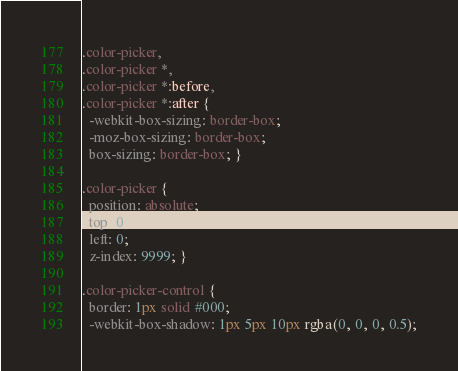Convert code to text. <code><loc_0><loc_0><loc_500><loc_500><_CSS_>.color-picker,
.color-picker *,
.color-picker *:before,
.color-picker *:after {
  -webkit-box-sizing: border-box;
  -moz-box-sizing: border-box;
  box-sizing: border-box; }

.color-picker {
  position: absolute;
  top: 0;
  left: 0;
  z-index: 9999; }

.color-picker-control {
  border: 1px solid #000;
  -webkit-box-shadow: 1px 5px 10px rgba(0, 0, 0, 0.5);</code> 